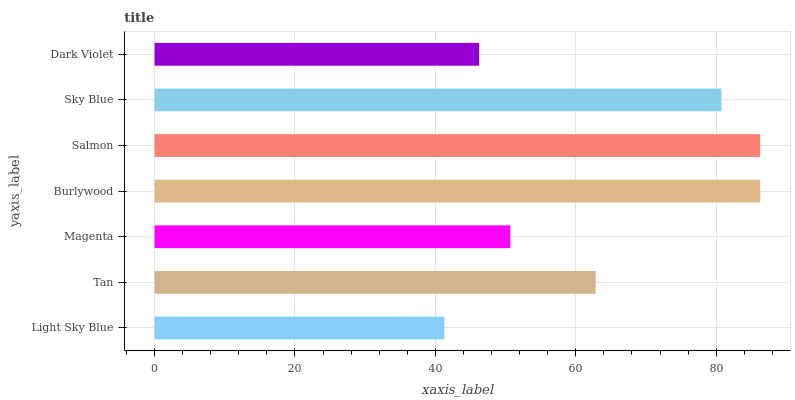Is Light Sky Blue the minimum?
Answer yes or no. Yes. Is Burlywood the maximum?
Answer yes or no. Yes. Is Tan the minimum?
Answer yes or no. No. Is Tan the maximum?
Answer yes or no. No. Is Tan greater than Light Sky Blue?
Answer yes or no. Yes. Is Light Sky Blue less than Tan?
Answer yes or no. Yes. Is Light Sky Blue greater than Tan?
Answer yes or no. No. Is Tan less than Light Sky Blue?
Answer yes or no. No. Is Tan the high median?
Answer yes or no. Yes. Is Tan the low median?
Answer yes or no. Yes. Is Sky Blue the high median?
Answer yes or no. No. Is Light Sky Blue the low median?
Answer yes or no. No. 